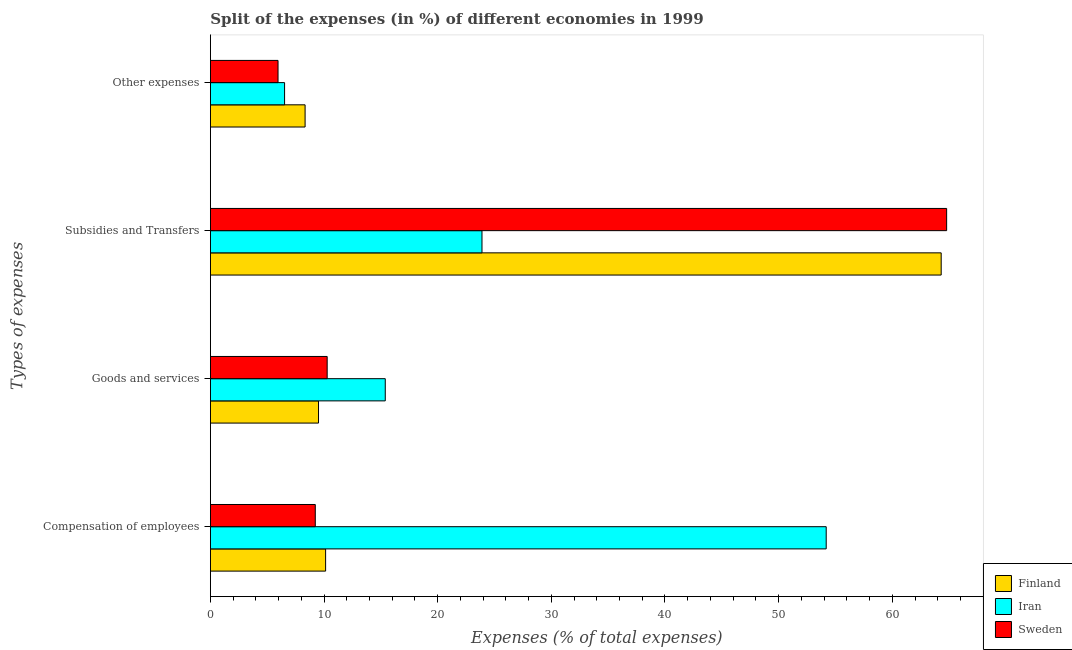Are the number of bars per tick equal to the number of legend labels?
Provide a short and direct response. Yes. How many bars are there on the 1st tick from the bottom?
Make the answer very short. 3. What is the label of the 3rd group of bars from the top?
Give a very brief answer. Goods and services. What is the percentage of amount spent on subsidies in Sweden?
Your answer should be very brief. 64.78. Across all countries, what is the maximum percentage of amount spent on compensation of employees?
Your response must be concise. 54.19. Across all countries, what is the minimum percentage of amount spent on goods and services?
Your response must be concise. 9.51. In which country was the percentage of amount spent on compensation of employees maximum?
Your answer should be compact. Iran. What is the total percentage of amount spent on goods and services in the graph?
Your response must be concise. 35.18. What is the difference between the percentage of amount spent on subsidies in Iran and that in Sweden?
Ensure brevity in your answer.  -40.89. What is the difference between the percentage of amount spent on other expenses in Finland and the percentage of amount spent on goods and services in Sweden?
Provide a short and direct response. -1.94. What is the average percentage of amount spent on goods and services per country?
Offer a terse response. 11.73. What is the difference between the percentage of amount spent on subsidies and percentage of amount spent on goods and services in Finland?
Offer a terse response. 54.79. What is the ratio of the percentage of amount spent on subsidies in Sweden to that in Finland?
Ensure brevity in your answer.  1.01. Is the difference between the percentage of amount spent on goods and services in Sweden and Iran greater than the difference between the percentage of amount spent on other expenses in Sweden and Iran?
Offer a very short reply. No. What is the difference between the highest and the second highest percentage of amount spent on goods and services?
Make the answer very short. 5.11. What is the difference between the highest and the lowest percentage of amount spent on compensation of employees?
Your answer should be very brief. 44.96. What does the 2nd bar from the top in Subsidies and Transfers represents?
Your answer should be very brief. Iran. What does the 2nd bar from the bottom in Compensation of employees represents?
Your answer should be compact. Iran. Does the graph contain any zero values?
Offer a terse response. No. Where does the legend appear in the graph?
Offer a terse response. Bottom right. How many legend labels are there?
Give a very brief answer. 3. What is the title of the graph?
Make the answer very short. Split of the expenses (in %) of different economies in 1999. Does "Colombia" appear as one of the legend labels in the graph?
Your response must be concise. No. What is the label or title of the X-axis?
Keep it short and to the point. Expenses (% of total expenses). What is the label or title of the Y-axis?
Provide a short and direct response. Types of expenses. What is the Expenses (% of total expenses) of Finland in Compensation of employees?
Ensure brevity in your answer.  10.14. What is the Expenses (% of total expenses) of Iran in Compensation of employees?
Ensure brevity in your answer.  54.19. What is the Expenses (% of total expenses) of Sweden in Compensation of employees?
Your answer should be very brief. 9.23. What is the Expenses (% of total expenses) in Finland in Goods and services?
Give a very brief answer. 9.51. What is the Expenses (% of total expenses) in Iran in Goods and services?
Your answer should be very brief. 15.39. What is the Expenses (% of total expenses) in Sweden in Goods and services?
Offer a very short reply. 10.28. What is the Expenses (% of total expenses) of Finland in Subsidies and Transfers?
Your answer should be very brief. 64.3. What is the Expenses (% of total expenses) of Iran in Subsidies and Transfers?
Your response must be concise. 23.9. What is the Expenses (% of total expenses) of Sweden in Subsidies and Transfers?
Your answer should be compact. 64.78. What is the Expenses (% of total expenses) in Finland in Other expenses?
Keep it short and to the point. 8.33. What is the Expenses (% of total expenses) of Iran in Other expenses?
Your response must be concise. 6.53. What is the Expenses (% of total expenses) of Sweden in Other expenses?
Give a very brief answer. 5.95. Across all Types of expenses, what is the maximum Expenses (% of total expenses) of Finland?
Make the answer very short. 64.3. Across all Types of expenses, what is the maximum Expenses (% of total expenses) in Iran?
Your response must be concise. 54.19. Across all Types of expenses, what is the maximum Expenses (% of total expenses) in Sweden?
Your response must be concise. 64.78. Across all Types of expenses, what is the minimum Expenses (% of total expenses) of Finland?
Keep it short and to the point. 8.33. Across all Types of expenses, what is the minimum Expenses (% of total expenses) in Iran?
Your response must be concise. 6.53. Across all Types of expenses, what is the minimum Expenses (% of total expenses) in Sweden?
Your answer should be compact. 5.95. What is the total Expenses (% of total expenses) in Finland in the graph?
Make the answer very short. 92.29. What is the total Expenses (% of total expenses) in Iran in the graph?
Make the answer very short. 100. What is the total Expenses (% of total expenses) of Sweden in the graph?
Make the answer very short. 90.24. What is the difference between the Expenses (% of total expenses) of Finland in Compensation of employees and that in Goods and services?
Your response must be concise. 0.62. What is the difference between the Expenses (% of total expenses) in Iran in Compensation of employees and that in Goods and services?
Your answer should be compact. 38.8. What is the difference between the Expenses (% of total expenses) of Sweden in Compensation of employees and that in Goods and services?
Ensure brevity in your answer.  -1.05. What is the difference between the Expenses (% of total expenses) of Finland in Compensation of employees and that in Subsidies and Transfers?
Provide a short and direct response. -54.17. What is the difference between the Expenses (% of total expenses) in Iran in Compensation of employees and that in Subsidies and Transfers?
Ensure brevity in your answer.  30.29. What is the difference between the Expenses (% of total expenses) in Sweden in Compensation of employees and that in Subsidies and Transfers?
Offer a very short reply. -55.55. What is the difference between the Expenses (% of total expenses) in Finland in Compensation of employees and that in Other expenses?
Keep it short and to the point. 1.8. What is the difference between the Expenses (% of total expenses) of Iran in Compensation of employees and that in Other expenses?
Give a very brief answer. 47.66. What is the difference between the Expenses (% of total expenses) of Sweden in Compensation of employees and that in Other expenses?
Give a very brief answer. 3.28. What is the difference between the Expenses (% of total expenses) of Finland in Goods and services and that in Subsidies and Transfers?
Offer a terse response. -54.79. What is the difference between the Expenses (% of total expenses) in Iran in Goods and services and that in Subsidies and Transfers?
Provide a short and direct response. -8.51. What is the difference between the Expenses (% of total expenses) of Sweden in Goods and services and that in Subsidies and Transfers?
Offer a very short reply. -54.51. What is the difference between the Expenses (% of total expenses) in Finland in Goods and services and that in Other expenses?
Your response must be concise. 1.18. What is the difference between the Expenses (% of total expenses) in Iran in Goods and services and that in Other expenses?
Your response must be concise. 8.86. What is the difference between the Expenses (% of total expenses) of Sweden in Goods and services and that in Other expenses?
Keep it short and to the point. 4.32. What is the difference between the Expenses (% of total expenses) in Finland in Subsidies and Transfers and that in Other expenses?
Offer a very short reply. 55.97. What is the difference between the Expenses (% of total expenses) of Iran in Subsidies and Transfers and that in Other expenses?
Give a very brief answer. 17.37. What is the difference between the Expenses (% of total expenses) of Sweden in Subsidies and Transfers and that in Other expenses?
Offer a terse response. 58.83. What is the difference between the Expenses (% of total expenses) in Finland in Compensation of employees and the Expenses (% of total expenses) in Iran in Goods and services?
Offer a very short reply. -5.25. What is the difference between the Expenses (% of total expenses) of Finland in Compensation of employees and the Expenses (% of total expenses) of Sweden in Goods and services?
Give a very brief answer. -0.14. What is the difference between the Expenses (% of total expenses) of Iran in Compensation of employees and the Expenses (% of total expenses) of Sweden in Goods and services?
Your response must be concise. 43.91. What is the difference between the Expenses (% of total expenses) in Finland in Compensation of employees and the Expenses (% of total expenses) in Iran in Subsidies and Transfers?
Give a very brief answer. -13.76. What is the difference between the Expenses (% of total expenses) of Finland in Compensation of employees and the Expenses (% of total expenses) of Sweden in Subsidies and Transfers?
Provide a short and direct response. -54.64. What is the difference between the Expenses (% of total expenses) in Iran in Compensation of employees and the Expenses (% of total expenses) in Sweden in Subsidies and Transfers?
Provide a short and direct response. -10.6. What is the difference between the Expenses (% of total expenses) in Finland in Compensation of employees and the Expenses (% of total expenses) in Iran in Other expenses?
Your response must be concise. 3.61. What is the difference between the Expenses (% of total expenses) in Finland in Compensation of employees and the Expenses (% of total expenses) in Sweden in Other expenses?
Ensure brevity in your answer.  4.19. What is the difference between the Expenses (% of total expenses) in Iran in Compensation of employees and the Expenses (% of total expenses) in Sweden in Other expenses?
Offer a very short reply. 48.23. What is the difference between the Expenses (% of total expenses) of Finland in Goods and services and the Expenses (% of total expenses) of Iran in Subsidies and Transfers?
Offer a very short reply. -14.38. What is the difference between the Expenses (% of total expenses) of Finland in Goods and services and the Expenses (% of total expenses) of Sweden in Subsidies and Transfers?
Offer a very short reply. -55.27. What is the difference between the Expenses (% of total expenses) of Iran in Goods and services and the Expenses (% of total expenses) of Sweden in Subsidies and Transfers?
Your answer should be very brief. -49.4. What is the difference between the Expenses (% of total expenses) in Finland in Goods and services and the Expenses (% of total expenses) in Iran in Other expenses?
Provide a short and direct response. 2.99. What is the difference between the Expenses (% of total expenses) of Finland in Goods and services and the Expenses (% of total expenses) of Sweden in Other expenses?
Offer a terse response. 3.56. What is the difference between the Expenses (% of total expenses) in Iran in Goods and services and the Expenses (% of total expenses) in Sweden in Other expenses?
Your answer should be very brief. 9.44. What is the difference between the Expenses (% of total expenses) of Finland in Subsidies and Transfers and the Expenses (% of total expenses) of Iran in Other expenses?
Make the answer very short. 57.78. What is the difference between the Expenses (% of total expenses) in Finland in Subsidies and Transfers and the Expenses (% of total expenses) in Sweden in Other expenses?
Ensure brevity in your answer.  58.35. What is the difference between the Expenses (% of total expenses) of Iran in Subsidies and Transfers and the Expenses (% of total expenses) of Sweden in Other expenses?
Keep it short and to the point. 17.95. What is the average Expenses (% of total expenses) in Finland per Types of expenses?
Provide a short and direct response. 23.07. What is the average Expenses (% of total expenses) in Iran per Types of expenses?
Your response must be concise. 25. What is the average Expenses (% of total expenses) of Sweden per Types of expenses?
Your response must be concise. 22.56. What is the difference between the Expenses (% of total expenses) of Finland and Expenses (% of total expenses) of Iran in Compensation of employees?
Give a very brief answer. -44.05. What is the difference between the Expenses (% of total expenses) of Finland and Expenses (% of total expenses) of Sweden in Compensation of employees?
Provide a short and direct response. 0.91. What is the difference between the Expenses (% of total expenses) in Iran and Expenses (% of total expenses) in Sweden in Compensation of employees?
Ensure brevity in your answer.  44.96. What is the difference between the Expenses (% of total expenses) of Finland and Expenses (% of total expenses) of Iran in Goods and services?
Your answer should be very brief. -5.87. What is the difference between the Expenses (% of total expenses) of Finland and Expenses (% of total expenses) of Sweden in Goods and services?
Your answer should be compact. -0.76. What is the difference between the Expenses (% of total expenses) of Iran and Expenses (% of total expenses) of Sweden in Goods and services?
Your answer should be very brief. 5.11. What is the difference between the Expenses (% of total expenses) of Finland and Expenses (% of total expenses) of Iran in Subsidies and Transfers?
Keep it short and to the point. 40.41. What is the difference between the Expenses (% of total expenses) of Finland and Expenses (% of total expenses) of Sweden in Subsidies and Transfers?
Offer a very short reply. -0.48. What is the difference between the Expenses (% of total expenses) of Iran and Expenses (% of total expenses) of Sweden in Subsidies and Transfers?
Your answer should be very brief. -40.89. What is the difference between the Expenses (% of total expenses) of Finland and Expenses (% of total expenses) of Iran in Other expenses?
Ensure brevity in your answer.  1.81. What is the difference between the Expenses (% of total expenses) of Finland and Expenses (% of total expenses) of Sweden in Other expenses?
Make the answer very short. 2.38. What is the difference between the Expenses (% of total expenses) in Iran and Expenses (% of total expenses) in Sweden in Other expenses?
Give a very brief answer. 0.58. What is the ratio of the Expenses (% of total expenses) of Finland in Compensation of employees to that in Goods and services?
Your answer should be compact. 1.07. What is the ratio of the Expenses (% of total expenses) of Iran in Compensation of employees to that in Goods and services?
Give a very brief answer. 3.52. What is the ratio of the Expenses (% of total expenses) in Sweden in Compensation of employees to that in Goods and services?
Ensure brevity in your answer.  0.9. What is the ratio of the Expenses (% of total expenses) in Finland in Compensation of employees to that in Subsidies and Transfers?
Your answer should be compact. 0.16. What is the ratio of the Expenses (% of total expenses) of Iran in Compensation of employees to that in Subsidies and Transfers?
Your response must be concise. 2.27. What is the ratio of the Expenses (% of total expenses) in Sweden in Compensation of employees to that in Subsidies and Transfers?
Offer a very short reply. 0.14. What is the ratio of the Expenses (% of total expenses) of Finland in Compensation of employees to that in Other expenses?
Your response must be concise. 1.22. What is the ratio of the Expenses (% of total expenses) of Iran in Compensation of employees to that in Other expenses?
Offer a very short reply. 8.3. What is the ratio of the Expenses (% of total expenses) of Sweden in Compensation of employees to that in Other expenses?
Provide a succinct answer. 1.55. What is the ratio of the Expenses (% of total expenses) of Finland in Goods and services to that in Subsidies and Transfers?
Your answer should be very brief. 0.15. What is the ratio of the Expenses (% of total expenses) of Iran in Goods and services to that in Subsidies and Transfers?
Offer a very short reply. 0.64. What is the ratio of the Expenses (% of total expenses) of Sweden in Goods and services to that in Subsidies and Transfers?
Your answer should be very brief. 0.16. What is the ratio of the Expenses (% of total expenses) of Finland in Goods and services to that in Other expenses?
Your response must be concise. 1.14. What is the ratio of the Expenses (% of total expenses) in Iran in Goods and services to that in Other expenses?
Your answer should be compact. 2.36. What is the ratio of the Expenses (% of total expenses) in Sweden in Goods and services to that in Other expenses?
Keep it short and to the point. 1.73. What is the ratio of the Expenses (% of total expenses) in Finland in Subsidies and Transfers to that in Other expenses?
Your answer should be compact. 7.72. What is the ratio of the Expenses (% of total expenses) in Iran in Subsidies and Transfers to that in Other expenses?
Your answer should be very brief. 3.66. What is the ratio of the Expenses (% of total expenses) of Sweden in Subsidies and Transfers to that in Other expenses?
Your answer should be compact. 10.88. What is the difference between the highest and the second highest Expenses (% of total expenses) in Finland?
Your answer should be very brief. 54.17. What is the difference between the highest and the second highest Expenses (% of total expenses) of Iran?
Your answer should be very brief. 30.29. What is the difference between the highest and the second highest Expenses (% of total expenses) of Sweden?
Provide a short and direct response. 54.51. What is the difference between the highest and the lowest Expenses (% of total expenses) in Finland?
Your answer should be very brief. 55.97. What is the difference between the highest and the lowest Expenses (% of total expenses) in Iran?
Keep it short and to the point. 47.66. What is the difference between the highest and the lowest Expenses (% of total expenses) of Sweden?
Provide a succinct answer. 58.83. 